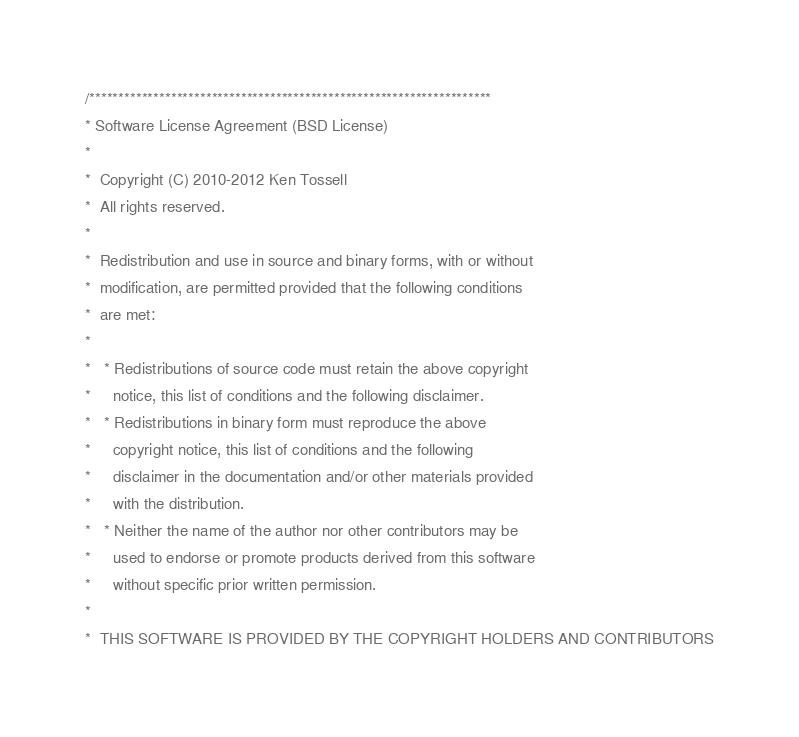Convert code to text. <code><loc_0><loc_0><loc_500><loc_500><_C_>/*********************************************************************
* Software License Agreement (BSD License)
*
*  Copyright (C) 2010-2012 Ken Tossell
*  All rights reserved.
*
*  Redistribution and use in source and binary forms, with or without
*  modification, are permitted provided that the following conditions
*  are met:
*
*   * Redistributions of source code must retain the above copyright
*     notice, this list of conditions and the following disclaimer.
*   * Redistributions in binary form must reproduce the above
*     copyright notice, this list of conditions and the following
*     disclaimer in the documentation and/or other materials provided
*     with the distribution.
*   * Neither the name of the author nor other contributors may be
*     used to endorse or promote products derived from this software
*     without specific prior written permission.
*
*  THIS SOFTWARE IS PROVIDED BY THE COPYRIGHT HOLDERS AND CONTRIBUTORS</code> 